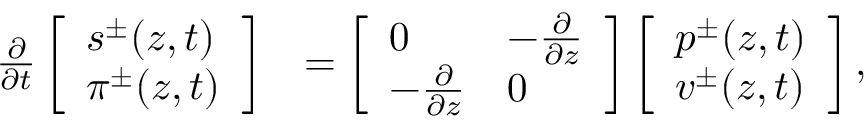<formula> <loc_0><loc_0><loc_500><loc_500>\begin{array} { r l } { \frac { \partial } { \partial t } \left [ \begin{array} { l } { s ^ { \pm } ( z , t ) } \\ { \pi ^ { \pm } ( z , t ) } \end{array} \right ] } & { = \left [ \begin{array} { l l } { 0 } & { - \frac { \partial } { \partial z } } \\ { - \frac { \partial } { \partial z } } & { 0 } \end{array} \right ] \left [ \begin{array} { l } { p ^ { \pm } ( z , t ) } \\ { v ^ { \pm } ( z , t ) } \end{array} \right ] , } \end{array}</formula> 